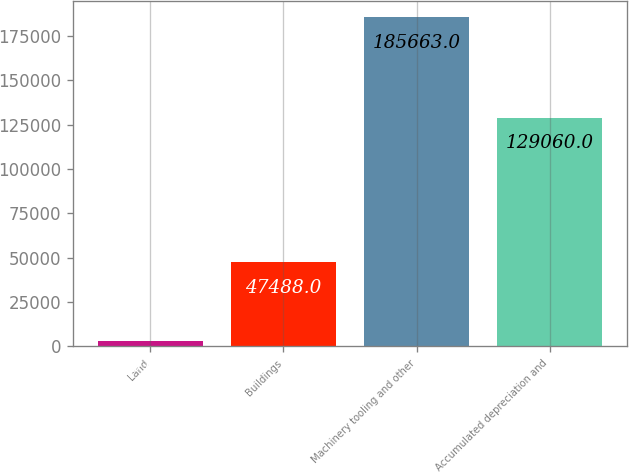Convert chart to OTSL. <chart><loc_0><loc_0><loc_500><loc_500><bar_chart><fcel>Land<fcel>Buildings<fcel>Machinery tooling and other<fcel>Accumulated depreciation and<nl><fcel>2912<fcel>47488<fcel>185663<fcel>129060<nl></chart> 